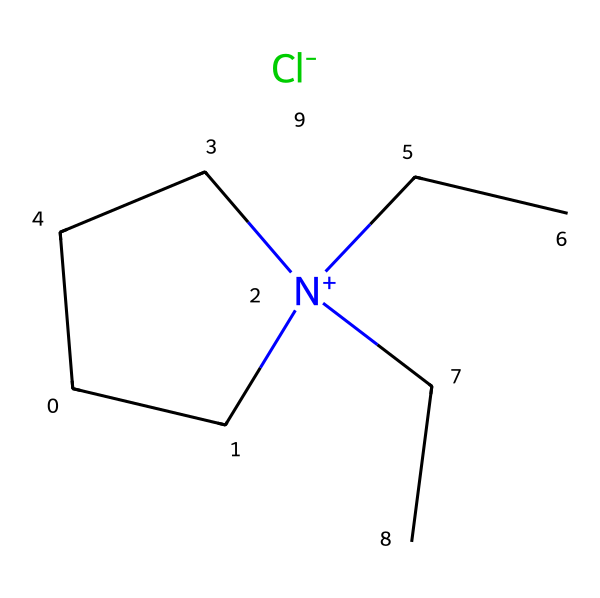What is the main cation in this ionic liquid? By examining the structure, the central part includes a nitrogen atom with a positive charge, surrounded by carbon chains (C1C). This nitrogen (N+) represents the cationic component of the ionic liquid.
Answer: N+ How many carbon atoms are present in the structure? The structure shows a total of six carbon atoms, as indicated by the carbon atoms surrounding the nitrogen and at the terminal parts of the molecule.
Answer: six What is the anion associated with this ionic liquid? The chemical structure specifies the presence of a chloride ion (Cl-) attached to the cation, identifying it as the anionic part of the ionic liquid.
Answer: Cl- Why might this ionic liquid be suitable for use in glow sticks? Ionic liquids have properties such as low volatility and thermal stability. Such properties allow for long-lasting luminescence and a stable environment for the chemical reaction required in glow sticks.
Answer: stability What state is this ionic liquid at room temperature? Given that ionic liquids generally are non-volatile salts that remain liquid at room temperature, observing the structure confirms it is in a liquid state due to its ionic nature.
Answer: liquid 